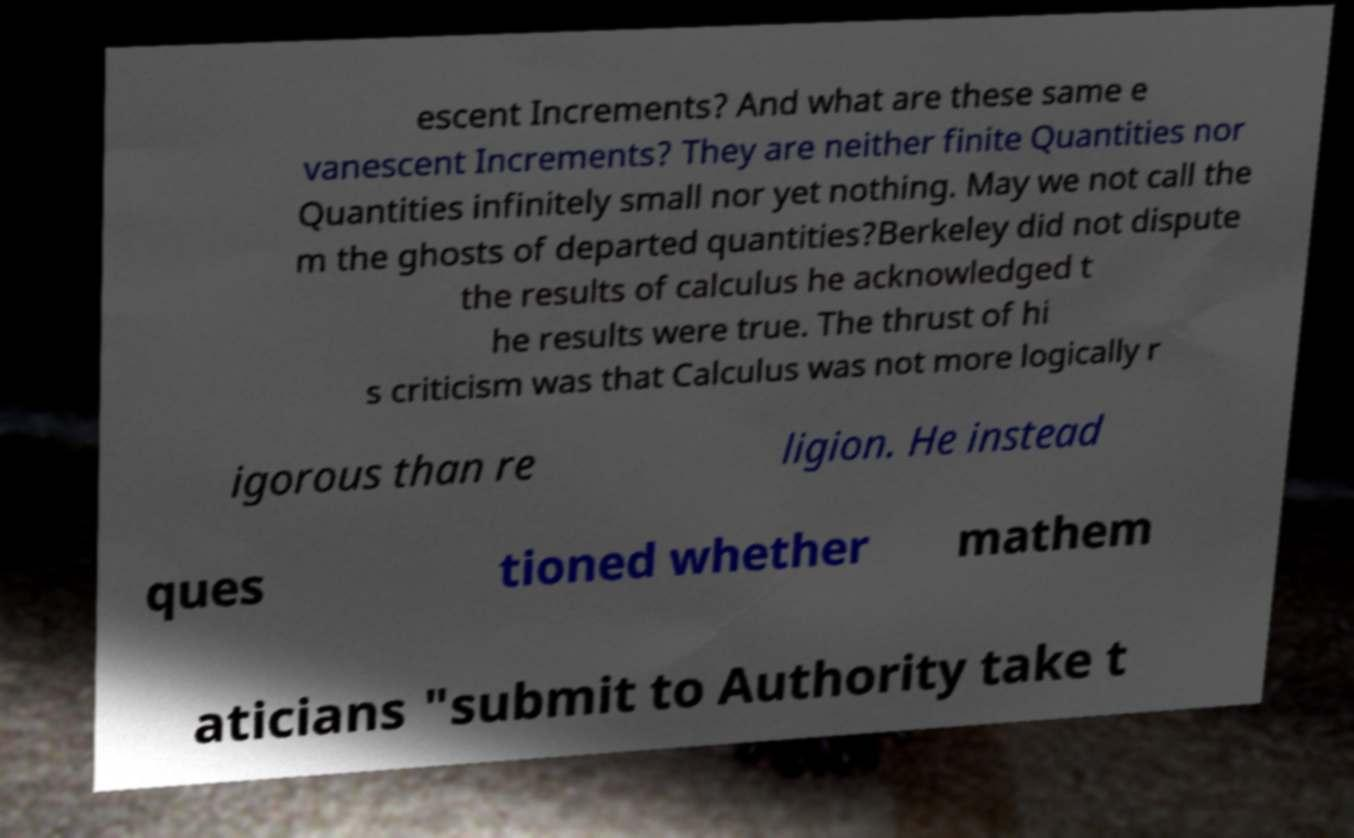I need the written content from this picture converted into text. Can you do that? escent Increments? And what are these same e vanescent Increments? They are neither finite Quantities nor Quantities infinitely small nor yet nothing. May we not call the m the ghosts of departed quantities?Berkeley did not dispute the results of calculus he acknowledged t he results were true. The thrust of hi s criticism was that Calculus was not more logically r igorous than re ligion. He instead ques tioned whether mathem aticians "submit to Authority take t 